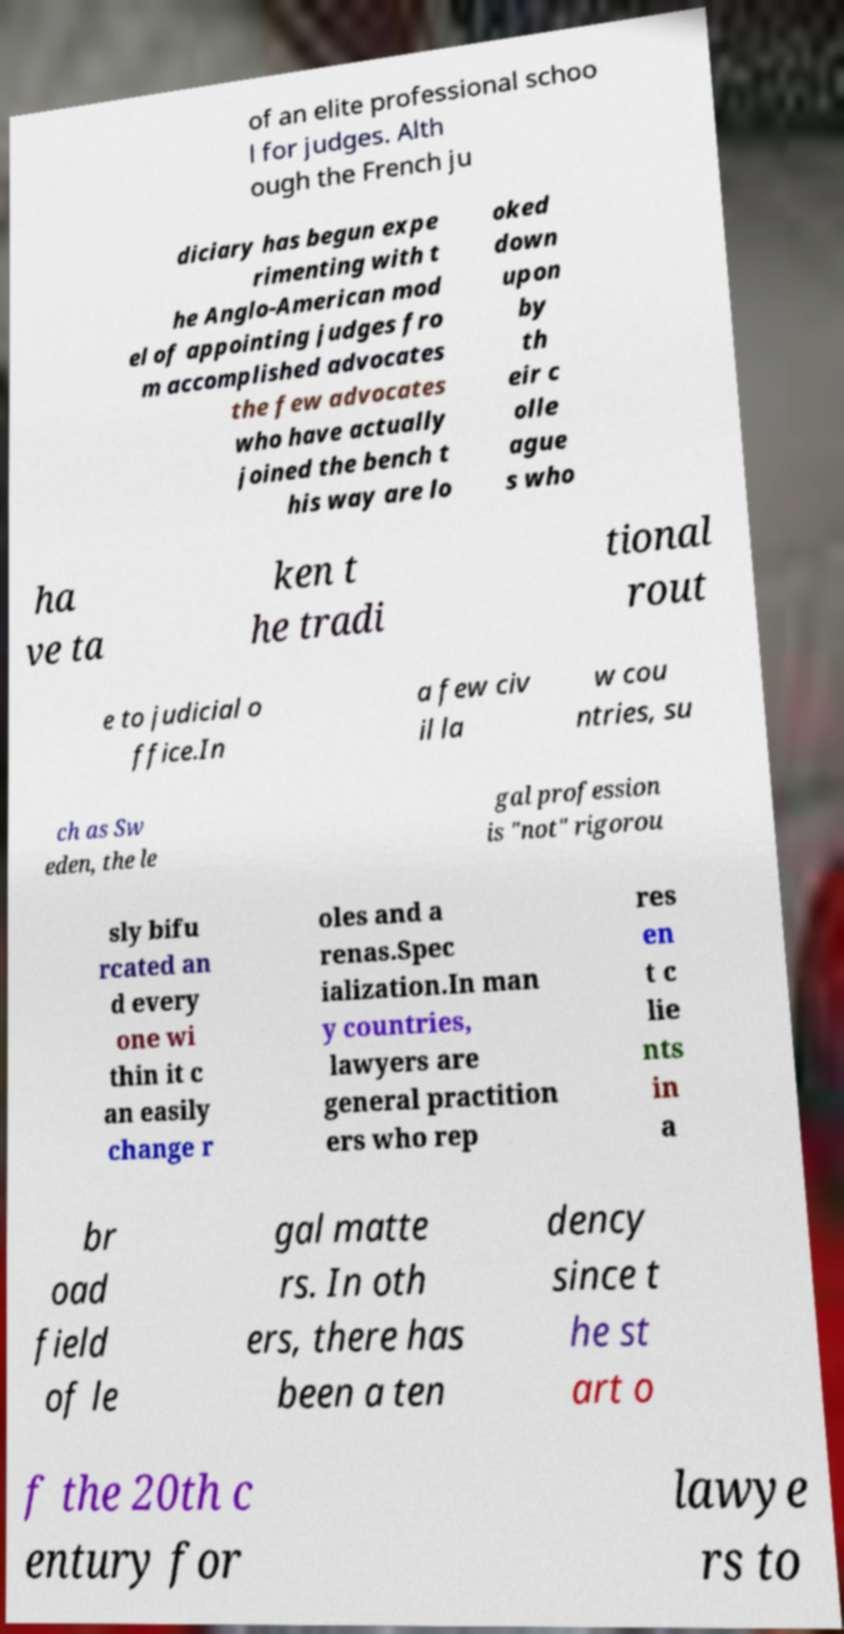Please read and relay the text visible in this image. What does it say? The text in the image appears to be an excerpt discussing the legal profession and the judiciary. It mentions the French judiciary experimenting with a model of appointing judges from accomplished advocates, and discusses the perception and treatment of such advocates. Additionally, it touches on the legal practice in countries like Sweden, where the legal profession isn't sharply divided and roles within it are more interchangeable. The text also indicates a general trend in many countries where lawyers are increasingly specializing in certain legal fields. 